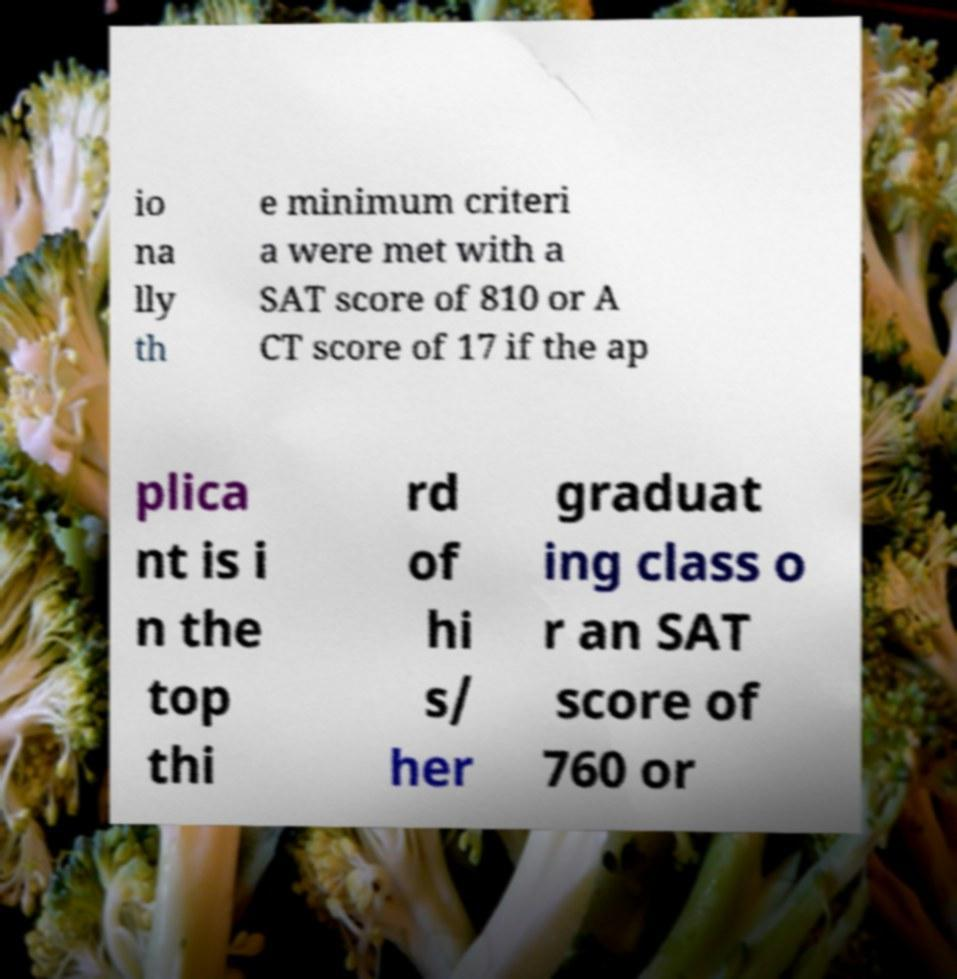For documentation purposes, I need the text within this image transcribed. Could you provide that? io na lly th e minimum criteri a were met with a SAT score of 810 or A CT score of 17 if the ap plica nt is i n the top thi rd of hi s/ her graduat ing class o r an SAT score of 760 or 